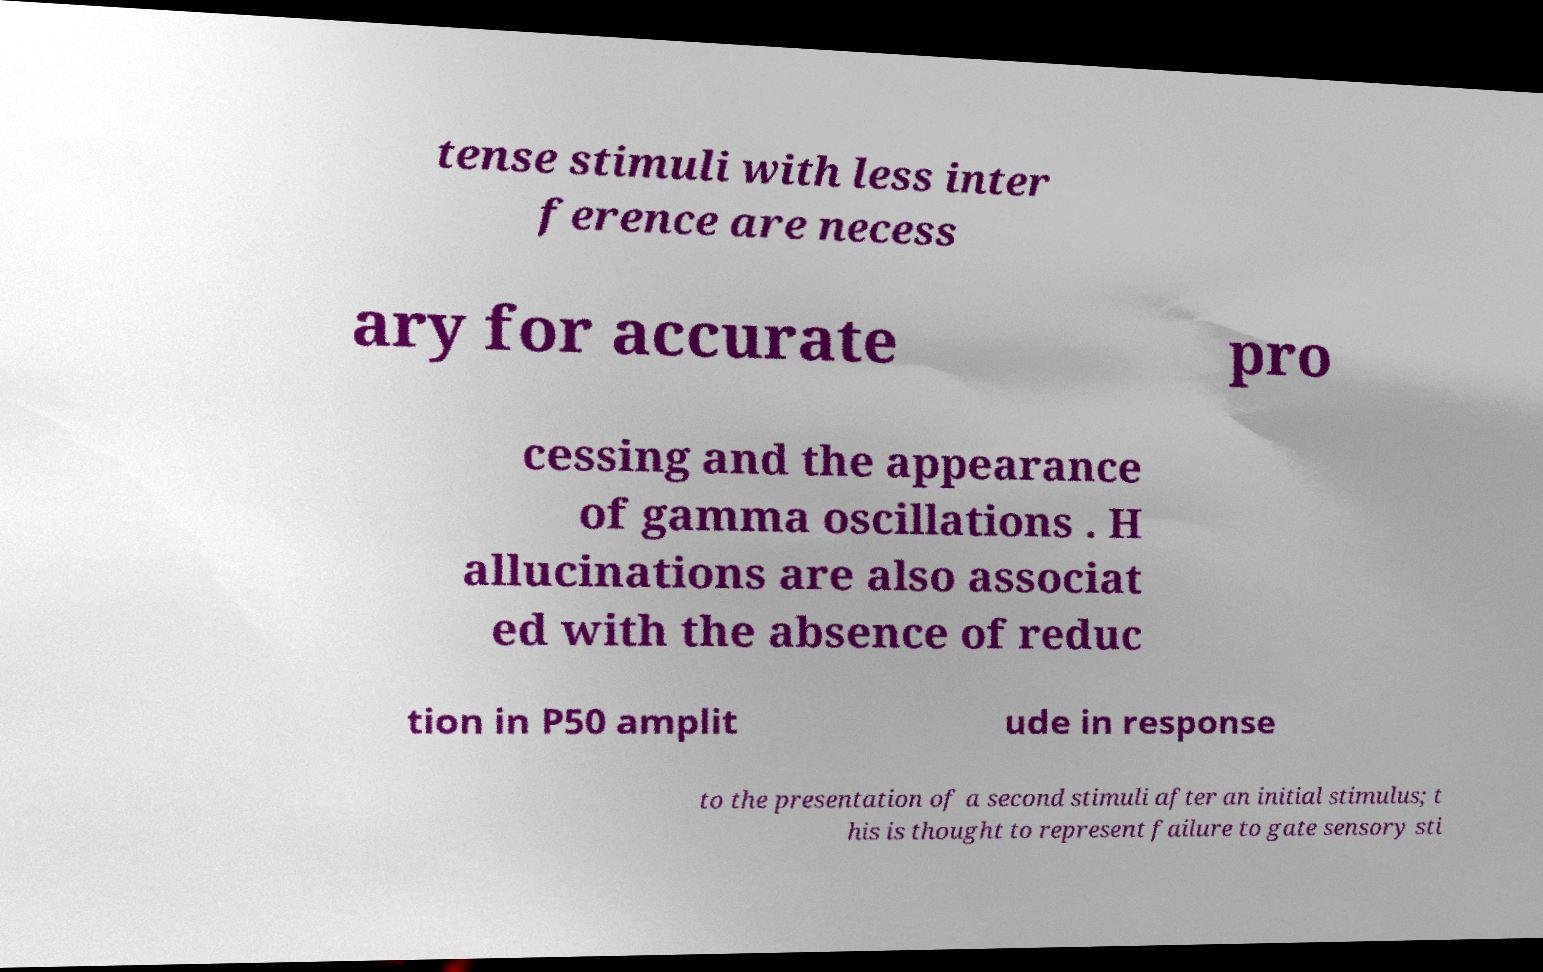What messages or text are displayed in this image? I need them in a readable, typed format. tense stimuli with less inter ference are necess ary for accurate pro cessing and the appearance of gamma oscillations . H allucinations are also associat ed with the absence of reduc tion in P50 amplit ude in response to the presentation of a second stimuli after an initial stimulus; t his is thought to represent failure to gate sensory sti 